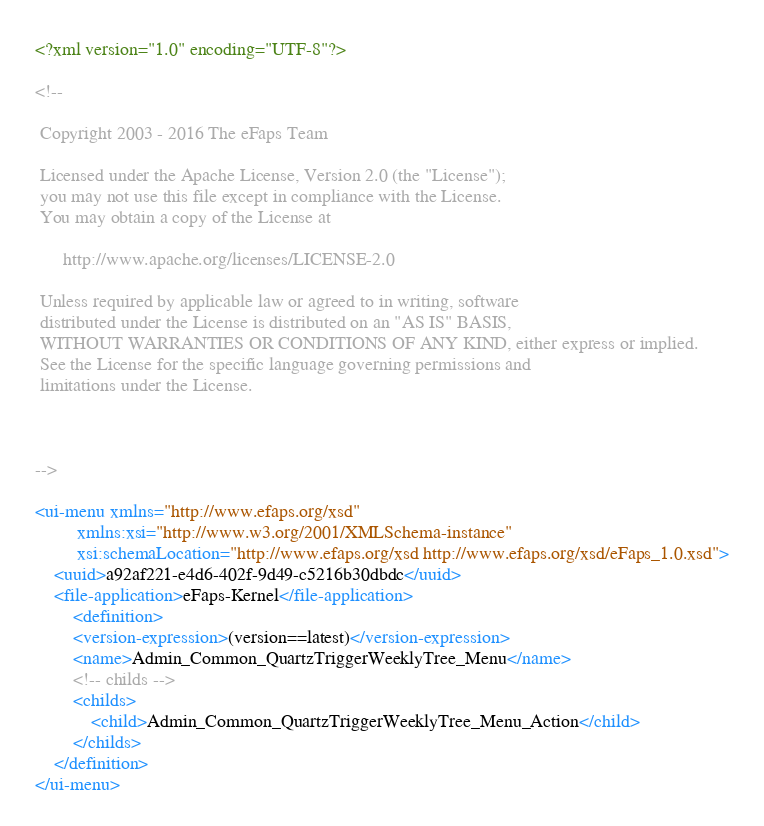Convert code to text. <code><loc_0><loc_0><loc_500><loc_500><_XML_><?xml version="1.0" encoding="UTF-8"?>

<!--

 Copyright 2003 - 2016 The eFaps Team

 Licensed under the Apache License, Version 2.0 (the "License");
 you may not use this file except in compliance with the License.
 You may obtain a copy of the License at

      http://www.apache.org/licenses/LICENSE-2.0

 Unless required by applicable law or agreed to in writing, software
 distributed under the License is distributed on an "AS IS" BASIS,
 WITHOUT WARRANTIES OR CONDITIONS OF ANY KIND, either express or implied.
 See the License for the specific language governing permissions and
 limitations under the License.



-->

<ui-menu xmlns="http://www.efaps.org/xsd"
         xmlns:xsi="http://www.w3.org/2001/XMLSchema-instance"
         xsi:schemaLocation="http://www.efaps.org/xsd http://www.efaps.org/xsd/eFaps_1.0.xsd">
    <uuid>a92af221-e4d6-402f-9d49-c5216b30dbdc</uuid>
    <file-application>eFaps-Kernel</file-application>
        <definition>
        <version-expression>(version==latest)</version-expression>
        <name>Admin_Common_QuartzTriggerWeeklyTree_Menu</name>
        <!-- childs -->
        <childs>
            <child>Admin_Common_QuartzTriggerWeeklyTree_Menu_Action</child>
        </childs>
    </definition>
</ui-menu>
</code> 